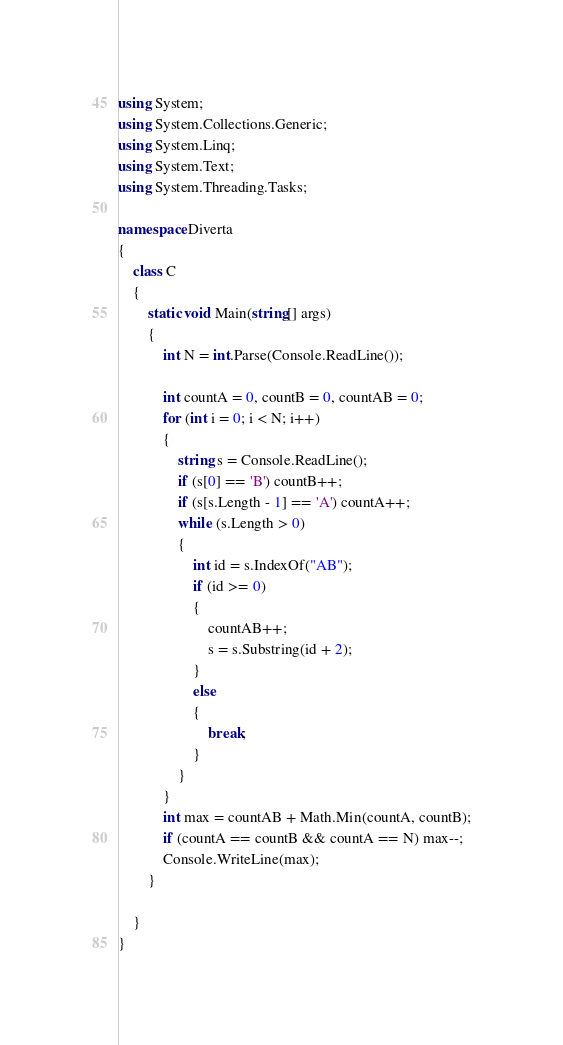<code> <loc_0><loc_0><loc_500><loc_500><_C#_>using System;
using System.Collections.Generic;
using System.Linq;
using System.Text;
using System.Threading.Tasks;

namespace Diverta
{
    class C
    {
        static void Main(string[] args)
        {
            int N = int.Parse(Console.ReadLine());

            int countA = 0, countB = 0, countAB = 0;
            for (int i = 0; i < N; i++)
            {
                string s = Console.ReadLine();
                if (s[0] == 'B') countB++;
                if (s[s.Length - 1] == 'A') countA++;
                while (s.Length > 0)
                {
                    int id = s.IndexOf("AB");
                    if (id >= 0)
                    {
                        countAB++;
                        s = s.Substring(id + 2);
                    }
                    else
                    {
                        break;
                    }
                }
            }
            int max = countAB + Math.Min(countA, countB);
            if (countA == countB && countA == N) max--;
            Console.WriteLine(max);
        }

    }
}
</code> 